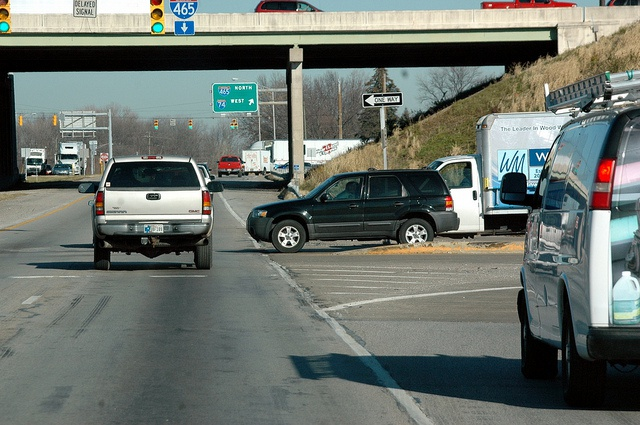Describe the objects in this image and their specific colors. I can see car in brown, black, gray, and white tones, car in brown, black, gray, teal, and darkgray tones, car in brown, black, ivory, gray, and darkgray tones, truck in brown, lightgray, black, gray, and darkgray tones, and truck in brown, lightgray, darkgray, gray, and black tones in this image. 